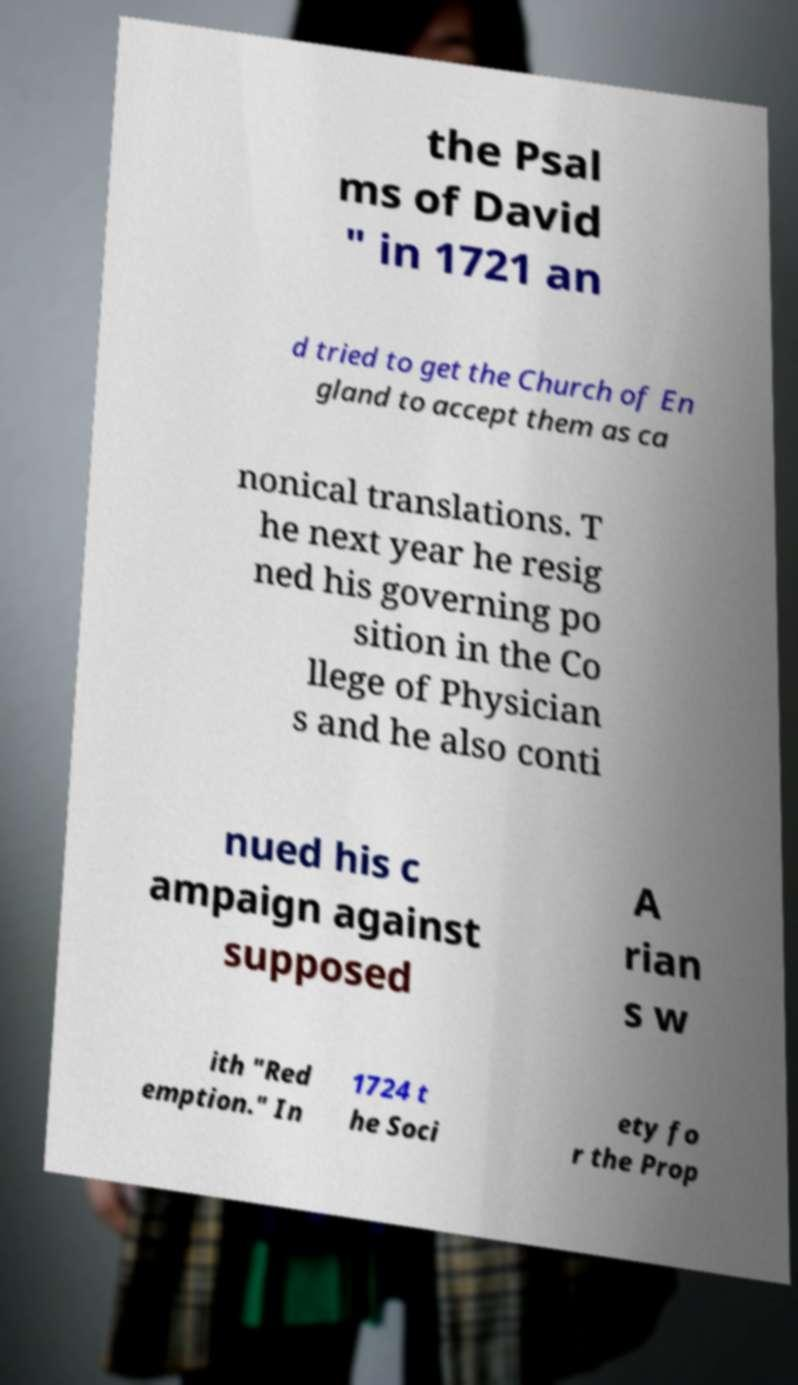Can you read and provide the text displayed in the image?This photo seems to have some interesting text. Can you extract and type it out for me? the Psal ms of David " in 1721 an d tried to get the Church of En gland to accept them as ca nonical translations. T he next year he resig ned his governing po sition in the Co llege of Physician s and he also conti nued his c ampaign against supposed A rian s w ith "Red emption." In 1724 t he Soci ety fo r the Prop 